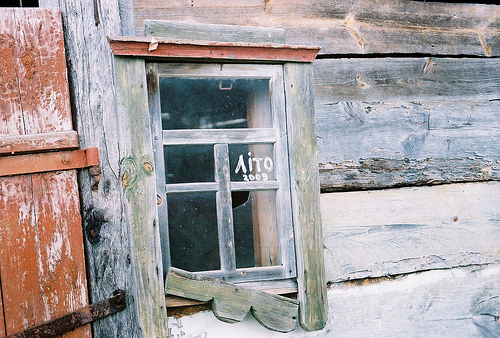<image>
Is there a window in front of the wall? No. The window is not in front of the wall. The spatial positioning shows a different relationship between these objects. 